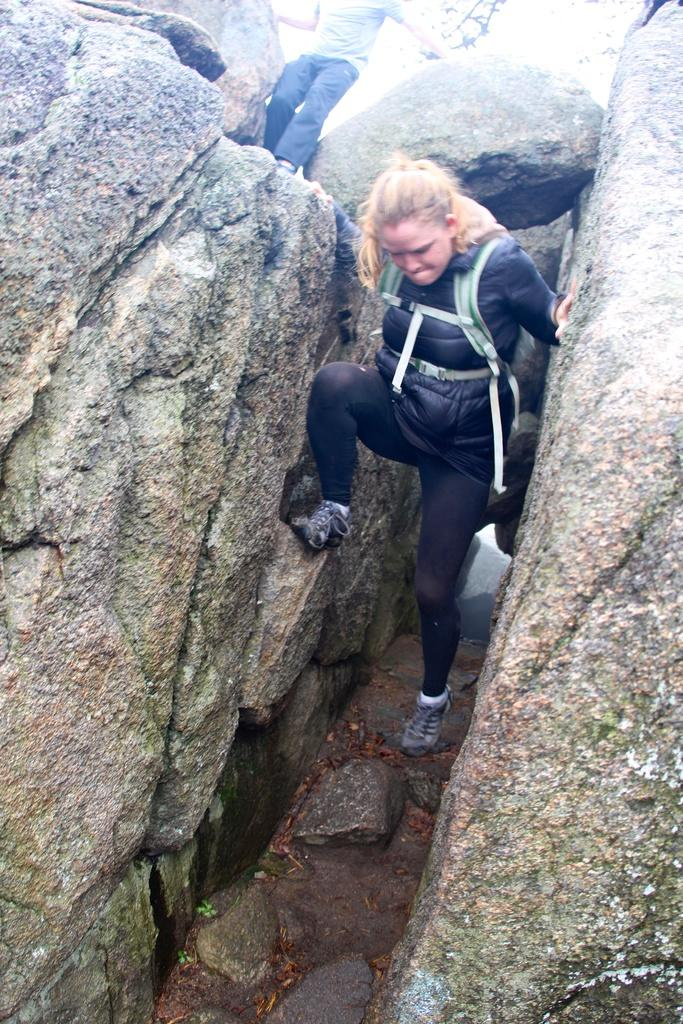What is the woman doing in the image? The woman is climbing a mountain in the image. Can you describe the person at the top of the mountain? There is a person standing at the top of the mountain in the image. What type of hearing aid is the goat wearing in the image? There is no goat present in the image, and therefore no hearing aid can be observed. 